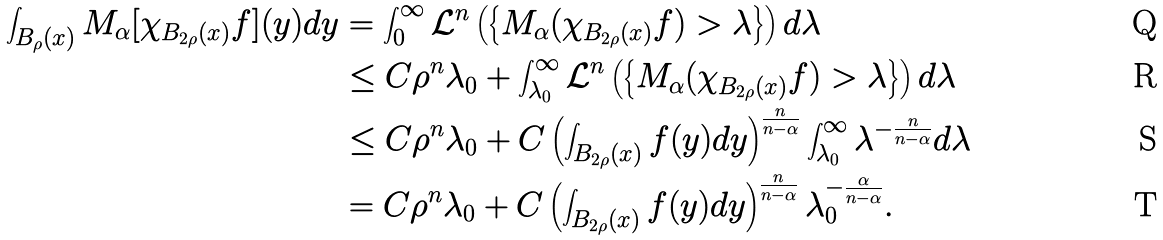Convert formula to latex. <formula><loc_0><loc_0><loc_500><loc_500>\int _ { B _ { \rho } ( x ) } M _ { \alpha } [ \chi _ { B _ { 2 \rho } ( x ) } f ] ( y ) d y & = \int _ { 0 } ^ { \infty } \mathcal { L } ^ { n } \left ( \left \{ M _ { \alpha } ( \chi _ { B _ { 2 \rho } ( x ) } f ) > \lambda \right \} \right ) d \lambda \\ & \leq C \rho ^ { n } \lambda _ { 0 } + \int _ { \lambda _ { 0 } } ^ { \infty } \mathcal { L } ^ { n } \left ( \left \{ M _ { \alpha } ( \chi _ { B _ { 2 \rho } ( x ) } f ) > \lambda \right \} \right ) d \lambda \\ & \leq C \rho ^ { n } \lambda _ { 0 } + C \left ( \int _ { B _ { 2 \rho } ( x ) } f ( y ) d y \right ) ^ { \frac { n } { n - \alpha } } \int _ { \lambda _ { 0 } } ^ { \infty } \lambda ^ { - \frac { n } { n - \alpha } } d \lambda \\ & = C \rho ^ { n } \lambda _ { 0 } + C \left ( \int _ { B _ { 2 \rho } ( x ) } f ( y ) d y \right ) ^ { \frac { n } { n - \alpha } } \lambda _ { 0 } ^ { - \frac { \alpha } { n - \alpha } } .</formula> 